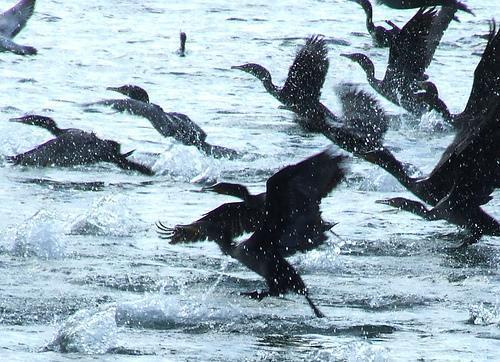How many birds are in the air?
Give a very brief answer. 10. How many birds are there?
Give a very brief answer. 7. 